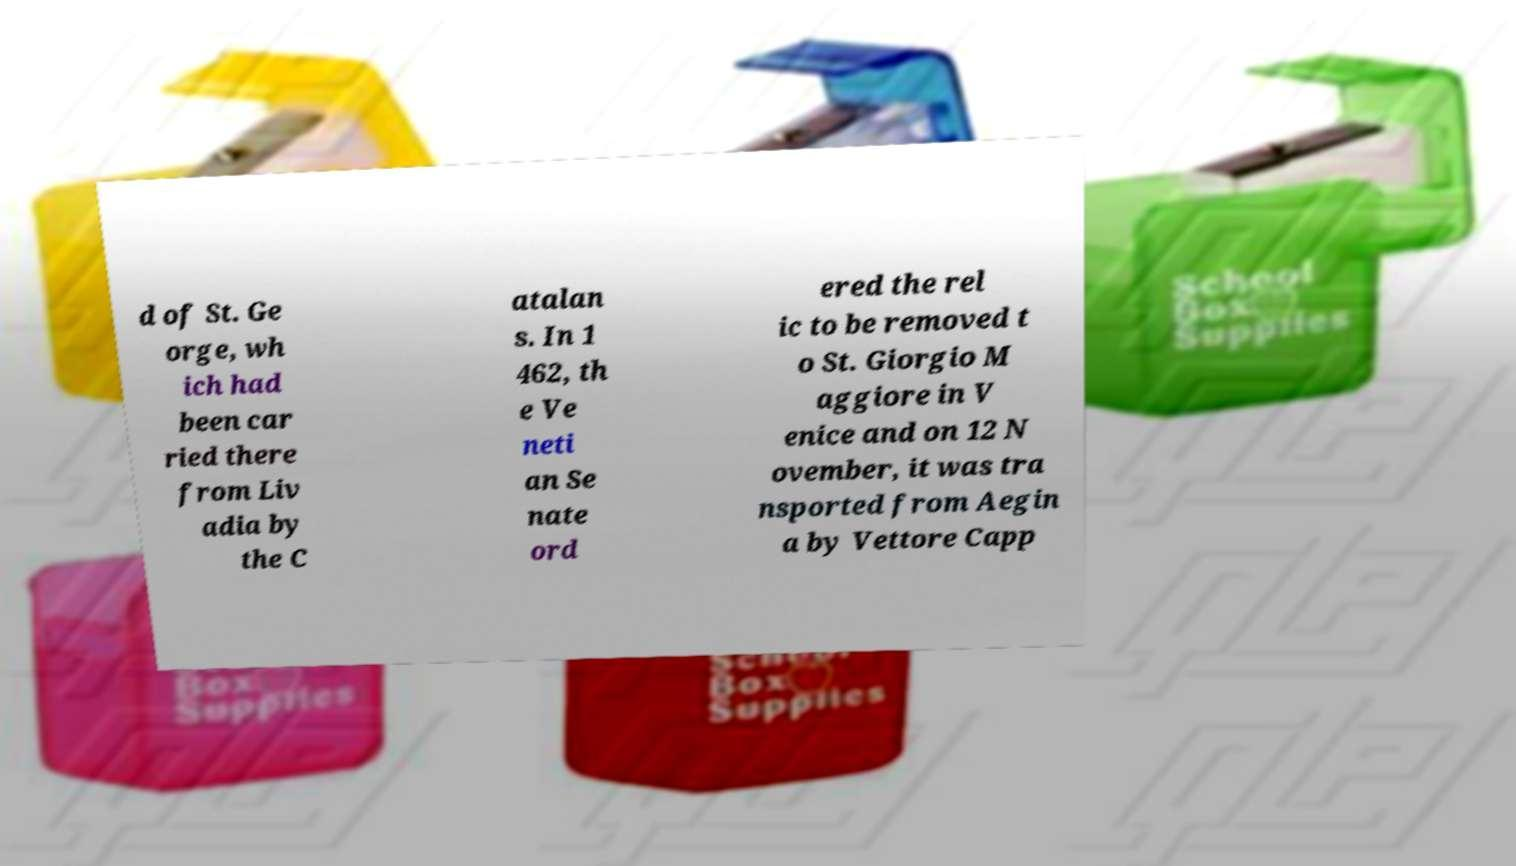Could you extract and type out the text from this image? d of St. Ge orge, wh ich had been car ried there from Liv adia by the C atalan s. In 1 462, th e Ve neti an Se nate ord ered the rel ic to be removed t o St. Giorgio M aggiore in V enice and on 12 N ovember, it was tra nsported from Aegin a by Vettore Capp 